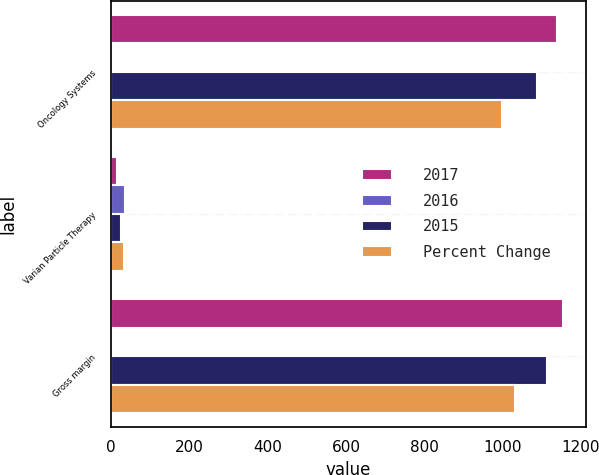Convert chart to OTSL. <chart><loc_0><loc_0><loc_500><loc_500><stacked_bar_chart><ecel><fcel>Oncology Systems<fcel>Varian Particle Therapy<fcel>Gross margin<nl><fcel>2017<fcel>1139.6<fcel>16<fcel>1155.6<nl><fcel>2016<fcel>5<fcel>36<fcel>4<nl><fcel>2015<fcel>1087.7<fcel>25.2<fcel>1112.9<nl><fcel>Percent Change<fcel>998.9<fcel>33.2<fcel>1032.1<nl></chart> 